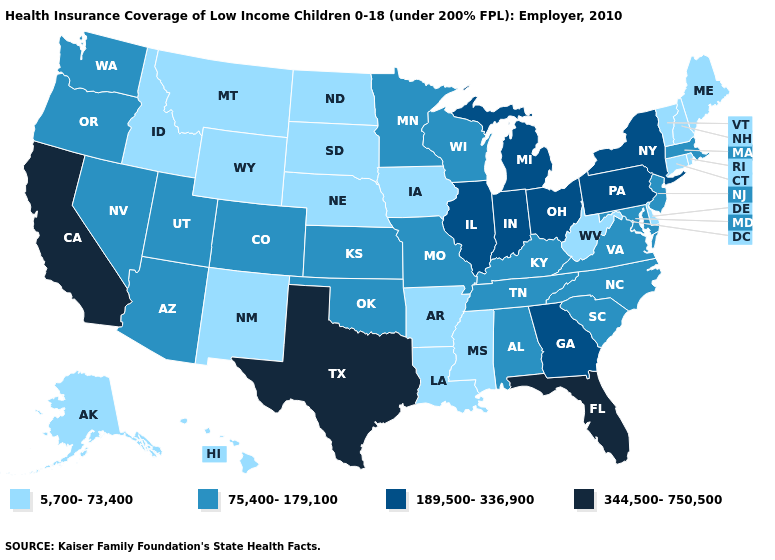What is the lowest value in the West?
Answer briefly. 5,700-73,400. Which states have the lowest value in the USA?
Give a very brief answer. Alaska, Arkansas, Connecticut, Delaware, Hawaii, Idaho, Iowa, Louisiana, Maine, Mississippi, Montana, Nebraska, New Hampshire, New Mexico, North Dakota, Rhode Island, South Dakota, Vermont, West Virginia, Wyoming. What is the value of Wisconsin?
Quick response, please. 75,400-179,100. Name the states that have a value in the range 75,400-179,100?
Quick response, please. Alabama, Arizona, Colorado, Kansas, Kentucky, Maryland, Massachusetts, Minnesota, Missouri, Nevada, New Jersey, North Carolina, Oklahoma, Oregon, South Carolina, Tennessee, Utah, Virginia, Washington, Wisconsin. Does Vermont have the same value as North Carolina?
Answer briefly. No. Name the states that have a value in the range 189,500-336,900?
Quick response, please. Georgia, Illinois, Indiana, Michigan, New York, Ohio, Pennsylvania. Name the states that have a value in the range 189,500-336,900?
Be succinct. Georgia, Illinois, Indiana, Michigan, New York, Ohio, Pennsylvania. What is the value of Kentucky?
Answer briefly. 75,400-179,100. Name the states that have a value in the range 5,700-73,400?
Short answer required. Alaska, Arkansas, Connecticut, Delaware, Hawaii, Idaho, Iowa, Louisiana, Maine, Mississippi, Montana, Nebraska, New Hampshire, New Mexico, North Dakota, Rhode Island, South Dakota, Vermont, West Virginia, Wyoming. Does Georgia have a lower value than Arkansas?
Answer briefly. No. Does Washington have the lowest value in the West?
Answer briefly. No. Name the states that have a value in the range 75,400-179,100?
Answer briefly. Alabama, Arizona, Colorado, Kansas, Kentucky, Maryland, Massachusetts, Minnesota, Missouri, Nevada, New Jersey, North Carolina, Oklahoma, Oregon, South Carolina, Tennessee, Utah, Virginia, Washington, Wisconsin. Which states have the highest value in the USA?
Concise answer only. California, Florida, Texas. What is the value of Wisconsin?
Keep it brief. 75,400-179,100. Which states hav the highest value in the MidWest?
Quick response, please. Illinois, Indiana, Michigan, Ohio. 